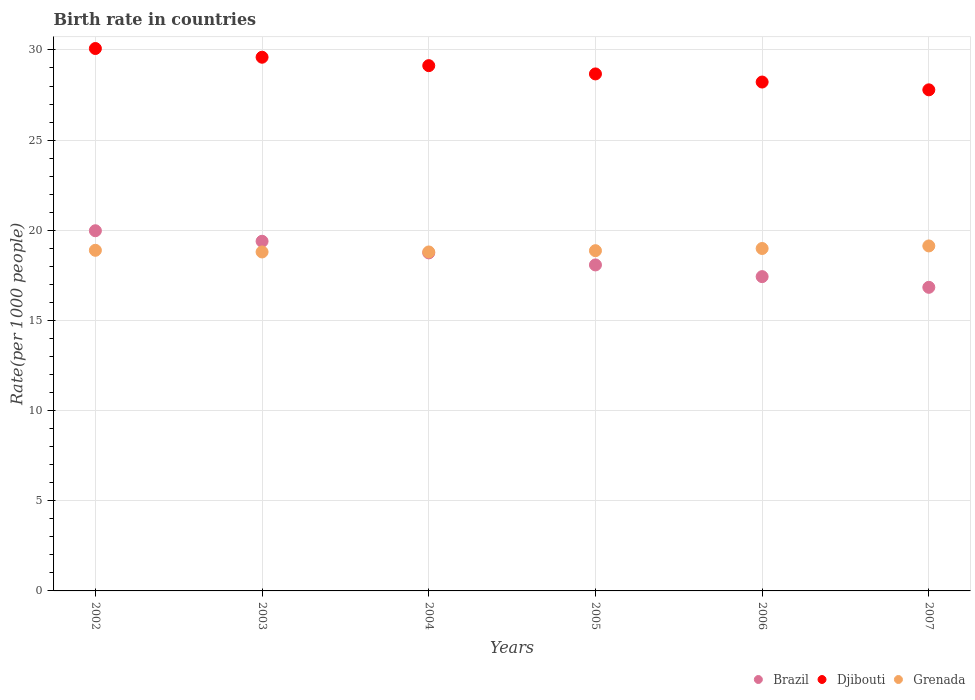What is the birth rate in Brazil in 2007?
Offer a terse response. 16.84. Across all years, what is the maximum birth rate in Grenada?
Offer a very short reply. 19.13. Across all years, what is the minimum birth rate in Brazil?
Offer a very short reply. 16.84. In which year was the birth rate in Brazil maximum?
Your response must be concise. 2002. In which year was the birth rate in Brazil minimum?
Your answer should be very brief. 2007. What is the total birth rate in Brazil in the graph?
Offer a very short reply. 110.45. What is the difference between the birth rate in Djibouti in 2006 and that in 2007?
Keep it short and to the point. 0.43. What is the difference between the birth rate in Djibouti in 2004 and the birth rate in Grenada in 2003?
Your answer should be compact. 10.33. What is the average birth rate in Brazil per year?
Your answer should be compact. 18.41. In the year 2005, what is the difference between the birth rate in Grenada and birth rate in Brazil?
Offer a very short reply. 0.79. What is the ratio of the birth rate in Djibouti in 2004 to that in 2005?
Your answer should be very brief. 1.02. Is the difference between the birth rate in Grenada in 2004 and 2007 greater than the difference between the birth rate in Brazil in 2004 and 2007?
Offer a very short reply. No. What is the difference between the highest and the second highest birth rate in Brazil?
Offer a terse response. 0.58. What is the difference between the highest and the lowest birth rate in Brazil?
Your answer should be compact. 3.14. In how many years, is the birth rate in Brazil greater than the average birth rate in Brazil taken over all years?
Your response must be concise. 3. Is the sum of the birth rate in Brazil in 2003 and 2004 greater than the maximum birth rate in Grenada across all years?
Provide a succinct answer. Yes. Is it the case that in every year, the sum of the birth rate in Brazil and birth rate in Grenada  is greater than the birth rate in Djibouti?
Your answer should be very brief. Yes. Does the birth rate in Brazil monotonically increase over the years?
Ensure brevity in your answer.  No. Is the birth rate in Djibouti strictly greater than the birth rate in Grenada over the years?
Provide a short and direct response. Yes. How many years are there in the graph?
Your response must be concise. 6. How many legend labels are there?
Make the answer very short. 3. How are the legend labels stacked?
Keep it short and to the point. Horizontal. What is the title of the graph?
Keep it short and to the point. Birth rate in countries. Does "Latin America(developing only)" appear as one of the legend labels in the graph?
Offer a very short reply. No. What is the label or title of the Y-axis?
Your response must be concise. Rate(per 1000 people). What is the Rate(per 1000 people) of Brazil in 2002?
Give a very brief answer. 19.97. What is the Rate(per 1000 people) of Djibouti in 2002?
Make the answer very short. 30.08. What is the Rate(per 1000 people) of Grenada in 2002?
Your response must be concise. 18.89. What is the Rate(per 1000 people) in Brazil in 2003?
Provide a short and direct response. 19.39. What is the Rate(per 1000 people) in Djibouti in 2003?
Keep it short and to the point. 29.6. What is the Rate(per 1000 people) of Grenada in 2003?
Offer a terse response. 18.8. What is the Rate(per 1000 people) in Brazil in 2004?
Make the answer very short. 18.75. What is the Rate(per 1000 people) in Djibouti in 2004?
Your answer should be very brief. 29.13. What is the Rate(per 1000 people) of Grenada in 2004?
Make the answer very short. 18.8. What is the Rate(per 1000 people) in Brazil in 2005?
Offer a terse response. 18.08. What is the Rate(per 1000 people) of Djibouti in 2005?
Your answer should be compact. 28.67. What is the Rate(per 1000 people) of Grenada in 2005?
Offer a very short reply. 18.87. What is the Rate(per 1000 people) in Brazil in 2006?
Make the answer very short. 17.43. What is the Rate(per 1000 people) in Djibouti in 2006?
Make the answer very short. 28.22. What is the Rate(per 1000 people) in Grenada in 2006?
Ensure brevity in your answer.  18.99. What is the Rate(per 1000 people) of Brazil in 2007?
Ensure brevity in your answer.  16.84. What is the Rate(per 1000 people) in Djibouti in 2007?
Your response must be concise. 27.79. What is the Rate(per 1000 people) in Grenada in 2007?
Your answer should be compact. 19.13. Across all years, what is the maximum Rate(per 1000 people) in Brazil?
Your answer should be very brief. 19.97. Across all years, what is the maximum Rate(per 1000 people) of Djibouti?
Provide a short and direct response. 30.08. Across all years, what is the maximum Rate(per 1000 people) in Grenada?
Make the answer very short. 19.13. Across all years, what is the minimum Rate(per 1000 people) of Brazil?
Keep it short and to the point. 16.84. Across all years, what is the minimum Rate(per 1000 people) in Djibouti?
Offer a very short reply. 27.79. Across all years, what is the minimum Rate(per 1000 people) of Grenada?
Keep it short and to the point. 18.8. What is the total Rate(per 1000 people) in Brazil in the graph?
Offer a very short reply. 110.45. What is the total Rate(per 1000 people) in Djibouti in the graph?
Your answer should be compact. 173.48. What is the total Rate(per 1000 people) of Grenada in the graph?
Provide a short and direct response. 113.47. What is the difference between the Rate(per 1000 people) of Brazil in 2002 and that in 2003?
Your response must be concise. 0.58. What is the difference between the Rate(per 1000 people) of Djibouti in 2002 and that in 2003?
Offer a very short reply. 0.48. What is the difference between the Rate(per 1000 people) in Grenada in 2002 and that in 2003?
Give a very brief answer. 0.09. What is the difference between the Rate(per 1000 people) of Brazil in 2002 and that in 2004?
Your response must be concise. 1.23. What is the difference between the Rate(per 1000 people) of Djibouti in 2002 and that in 2004?
Provide a succinct answer. 0.95. What is the difference between the Rate(per 1000 people) of Grenada in 2002 and that in 2004?
Your answer should be very brief. 0.09. What is the difference between the Rate(per 1000 people) in Brazil in 2002 and that in 2005?
Provide a succinct answer. 1.9. What is the difference between the Rate(per 1000 people) of Djibouti in 2002 and that in 2005?
Ensure brevity in your answer.  1.41. What is the difference between the Rate(per 1000 people) in Grenada in 2002 and that in 2005?
Provide a succinct answer. 0.02. What is the difference between the Rate(per 1000 people) of Brazil in 2002 and that in 2006?
Give a very brief answer. 2.54. What is the difference between the Rate(per 1000 people) of Djibouti in 2002 and that in 2006?
Your response must be concise. 1.86. What is the difference between the Rate(per 1000 people) in Brazil in 2002 and that in 2007?
Your answer should be compact. 3.14. What is the difference between the Rate(per 1000 people) of Djibouti in 2002 and that in 2007?
Give a very brief answer. 2.29. What is the difference between the Rate(per 1000 people) of Grenada in 2002 and that in 2007?
Make the answer very short. -0.24. What is the difference between the Rate(per 1000 people) in Brazil in 2003 and that in 2004?
Provide a succinct answer. 0.64. What is the difference between the Rate(per 1000 people) in Djibouti in 2003 and that in 2004?
Your answer should be very brief. 0.47. What is the difference between the Rate(per 1000 people) in Grenada in 2003 and that in 2004?
Your answer should be compact. 0. What is the difference between the Rate(per 1000 people) in Brazil in 2003 and that in 2005?
Make the answer very short. 1.31. What is the difference between the Rate(per 1000 people) of Djibouti in 2003 and that in 2005?
Provide a succinct answer. 0.93. What is the difference between the Rate(per 1000 people) in Grenada in 2003 and that in 2005?
Your response must be concise. -0.07. What is the difference between the Rate(per 1000 people) in Brazil in 2003 and that in 2006?
Provide a succinct answer. 1.96. What is the difference between the Rate(per 1000 people) of Djibouti in 2003 and that in 2006?
Make the answer very short. 1.38. What is the difference between the Rate(per 1000 people) in Grenada in 2003 and that in 2006?
Keep it short and to the point. -0.19. What is the difference between the Rate(per 1000 people) of Brazil in 2003 and that in 2007?
Offer a terse response. 2.55. What is the difference between the Rate(per 1000 people) in Djibouti in 2003 and that in 2007?
Make the answer very short. 1.81. What is the difference between the Rate(per 1000 people) of Grenada in 2003 and that in 2007?
Your answer should be very brief. -0.33. What is the difference between the Rate(per 1000 people) of Brazil in 2004 and that in 2005?
Offer a very short reply. 0.67. What is the difference between the Rate(per 1000 people) of Djibouti in 2004 and that in 2005?
Keep it short and to the point. 0.46. What is the difference between the Rate(per 1000 people) in Grenada in 2004 and that in 2005?
Your response must be concise. -0.07. What is the difference between the Rate(per 1000 people) of Brazil in 2004 and that in 2006?
Your answer should be very brief. 1.32. What is the difference between the Rate(per 1000 people) of Djibouti in 2004 and that in 2006?
Keep it short and to the point. 0.91. What is the difference between the Rate(per 1000 people) of Grenada in 2004 and that in 2006?
Make the answer very short. -0.19. What is the difference between the Rate(per 1000 people) of Brazil in 2004 and that in 2007?
Offer a terse response. 1.91. What is the difference between the Rate(per 1000 people) of Djibouti in 2004 and that in 2007?
Your response must be concise. 1.34. What is the difference between the Rate(per 1000 people) of Grenada in 2004 and that in 2007?
Ensure brevity in your answer.  -0.33. What is the difference between the Rate(per 1000 people) in Brazil in 2005 and that in 2006?
Keep it short and to the point. 0.65. What is the difference between the Rate(per 1000 people) in Djibouti in 2005 and that in 2006?
Your answer should be compact. 0.45. What is the difference between the Rate(per 1000 people) in Grenada in 2005 and that in 2006?
Make the answer very short. -0.12. What is the difference between the Rate(per 1000 people) in Brazil in 2005 and that in 2007?
Make the answer very short. 1.24. What is the difference between the Rate(per 1000 people) in Djibouti in 2005 and that in 2007?
Make the answer very short. 0.88. What is the difference between the Rate(per 1000 people) in Grenada in 2005 and that in 2007?
Give a very brief answer. -0.26. What is the difference between the Rate(per 1000 people) of Brazil in 2006 and that in 2007?
Your answer should be very brief. 0.59. What is the difference between the Rate(per 1000 people) in Djibouti in 2006 and that in 2007?
Ensure brevity in your answer.  0.43. What is the difference between the Rate(per 1000 people) in Grenada in 2006 and that in 2007?
Provide a short and direct response. -0.14. What is the difference between the Rate(per 1000 people) of Brazil in 2002 and the Rate(per 1000 people) of Djibouti in 2003?
Ensure brevity in your answer.  -9.62. What is the difference between the Rate(per 1000 people) of Brazil in 2002 and the Rate(per 1000 people) of Grenada in 2003?
Ensure brevity in your answer.  1.18. What is the difference between the Rate(per 1000 people) of Djibouti in 2002 and the Rate(per 1000 people) of Grenada in 2003?
Make the answer very short. 11.28. What is the difference between the Rate(per 1000 people) of Brazil in 2002 and the Rate(per 1000 people) of Djibouti in 2004?
Keep it short and to the point. -9.15. What is the difference between the Rate(per 1000 people) of Brazil in 2002 and the Rate(per 1000 people) of Grenada in 2004?
Offer a terse response. 1.18. What is the difference between the Rate(per 1000 people) of Djibouti in 2002 and the Rate(per 1000 people) of Grenada in 2004?
Provide a short and direct response. 11.28. What is the difference between the Rate(per 1000 people) in Brazil in 2002 and the Rate(per 1000 people) in Djibouti in 2005?
Provide a succinct answer. -8.7. What is the difference between the Rate(per 1000 people) in Brazil in 2002 and the Rate(per 1000 people) in Grenada in 2005?
Make the answer very short. 1.11. What is the difference between the Rate(per 1000 people) of Djibouti in 2002 and the Rate(per 1000 people) of Grenada in 2005?
Your answer should be very brief. 11.21. What is the difference between the Rate(per 1000 people) of Brazil in 2002 and the Rate(per 1000 people) of Djibouti in 2006?
Your answer should be very brief. -8.25. What is the difference between the Rate(per 1000 people) of Djibouti in 2002 and the Rate(per 1000 people) of Grenada in 2006?
Your answer should be very brief. 11.09. What is the difference between the Rate(per 1000 people) in Brazil in 2002 and the Rate(per 1000 people) in Djibouti in 2007?
Provide a short and direct response. -7.81. What is the difference between the Rate(per 1000 people) in Brazil in 2002 and the Rate(per 1000 people) in Grenada in 2007?
Your answer should be compact. 0.84. What is the difference between the Rate(per 1000 people) of Djibouti in 2002 and the Rate(per 1000 people) of Grenada in 2007?
Make the answer very short. 10.95. What is the difference between the Rate(per 1000 people) in Brazil in 2003 and the Rate(per 1000 people) in Djibouti in 2004?
Offer a very short reply. -9.74. What is the difference between the Rate(per 1000 people) in Brazil in 2003 and the Rate(per 1000 people) in Grenada in 2004?
Provide a succinct answer. 0.59. What is the difference between the Rate(per 1000 people) of Djibouti in 2003 and the Rate(per 1000 people) of Grenada in 2004?
Make the answer very short. 10.8. What is the difference between the Rate(per 1000 people) in Brazil in 2003 and the Rate(per 1000 people) in Djibouti in 2005?
Make the answer very short. -9.28. What is the difference between the Rate(per 1000 people) of Brazil in 2003 and the Rate(per 1000 people) of Grenada in 2005?
Make the answer very short. 0.52. What is the difference between the Rate(per 1000 people) of Djibouti in 2003 and the Rate(per 1000 people) of Grenada in 2005?
Provide a short and direct response. 10.73. What is the difference between the Rate(per 1000 people) of Brazil in 2003 and the Rate(per 1000 people) of Djibouti in 2006?
Your answer should be compact. -8.83. What is the difference between the Rate(per 1000 people) of Brazil in 2003 and the Rate(per 1000 people) of Grenada in 2006?
Offer a terse response. 0.4. What is the difference between the Rate(per 1000 people) in Djibouti in 2003 and the Rate(per 1000 people) in Grenada in 2006?
Make the answer very short. 10.61. What is the difference between the Rate(per 1000 people) in Brazil in 2003 and the Rate(per 1000 people) in Djibouti in 2007?
Your answer should be very brief. -8.4. What is the difference between the Rate(per 1000 people) in Brazil in 2003 and the Rate(per 1000 people) in Grenada in 2007?
Give a very brief answer. 0.26. What is the difference between the Rate(per 1000 people) of Djibouti in 2003 and the Rate(per 1000 people) of Grenada in 2007?
Make the answer very short. 10.46. What is the difference between the Rate(per 1000 people) of Brazil in 2004 and the Rate(per 1000 people) of Djibouti in 2005?
Keep it short and to the point. -9.92. What is the difference between the Rate(per 1000 people) of Brazil in 2004 and the Rate(per 1000 people) of Grenada in 2005?
Keep it short and to the point. -0.12. What is the difference between the Rate(per 1000 people) of Djibouti in 2004 and the Rate(per 1000 people) of Grenada in 2005?
Offer a terse response. 10.26. What is the difference between the Rate(per 1000 people) in Brazil in 2004 and the Rate(per 1000 people) in Djibouti in 2006?
Make the answer very short. -9.47. What is the difference between the Rate(per 1000 people) of Brazil in 2004 and the Rate(per 1000 people) of Grenada in 2006?
Give a very brief answer. -0.24. What is the difference between the Rate(per 1000 people) in Djibouti in 2004 and the Rate(per 1000 people) in Grenada in 2006?
Keep it short and to the point. 10.14. What is the difference between the Rate(per 1000 people) in Brazil in 2004 and the Rate(per 1000 people) in Djibouti in 2007?
Offer a very short reply. -9.04. What is the difference between the Rate(per 1000 people) in Brazil in 2004 and the Rate(per 1000 people) in Grenada in 2007?
Your answer should be very brief. -0.39. What is the difference between the Rate(per 1000 people) in Djibouti in 2004 and the Rate(per 1000 people) in Grenada in 2007?
Provide a short and direct response. 10. What is the difference between the Rate(per 1000 people) of Brazil in 2005 and the Rate(per 1000 people) of Djibouti in 2006?
Keep it short and to the point. -10.14. What is the difference between the Rate(per 1000 people) of Brazil in 2005 and the Rate(per 1000 people) of Grenada in 2006?
Your answer should be very brief. -0.91. What is the difference between the Rate(per 1000 people) of Djibouti in 2005 and the Rate(per 1000 people) of Grenada in 2006?
Your response must be concise. 9.68. What is the difference between the Rate(per 1000 people) of Brazil in 2005 and the Rate(per 1000 people) of Djibouti in 2007?
Keep it short and to the point. -9.71. What is the difference between the Rate(per 1000 people) in Brazil in 2005 and the Rate(per 1000 people) in Grenada in 2007?
Give a very brief answer. -1.05. What is the difference between the Rate(per 1000 people) in Djibouti in 2005 and the Rate(per 1000 people) in Grenada in 2007?
Keep it short and to the point. 9.54. What is the difference between the Rate(per 1000 people) in Brazil in 2006 and the Rate(per 1000 people) in Djibouti in 2007?
Your answer should be compact. -10.36. What is the difference between the Rate(per 1000 people) in Brazil in 2006 and the Rate(per 1000 people) in Grenada in 2007?
Offer a very short reply. -1.7. What is the difference between the Rate(per 1000 people) in Djibouti in 2006 and the Rate(per 1000 people) in Grenada in 2007?
Give a very brief answer. 9.09. What is the average Rate(per 1000 people) in Brazil per year?
Your answer should be very brief. 18.41. What is the average Rate(per 1000 people) of Djibouti per year?
Your response must be concise. 28.91. What is the average Rate(per 1000 people) in Grenada per year?
Give a very brief answer. 18.91. In the year 2002, what is the difference between the Rate(per 1000 people) of Brazil and Rate(per 1000 people) of Djibouti?
Your answer should be compact. -10.11. In the year 2002, what is the difference between the Rate(per 1000 people) in Brazil and Rate(per 1000 people) in Grenada?
Your answer should be compact. 1.08. In the year 2002, what is the difference between the Rate(per 1000 people) of Djibouti and Rate(per 1000 people) of Grenada?
Offer a terse response. 11.19. In the year 2003, what is the difference between the Rate(per 1000 people) of Brazil and Rate(per 1000 people) of Djibouti?
Provide a succinct answer. -10.21. In the year 2003, what is the difference between the Rate(per 1000 people) in Brazil and Rate(per 1000 people) in Grenada?
Ensure brevity in your answer.  0.59. In the year 2003, what is the difference between the Rate(per 1000 people) in Djibouti and Rate(per 1000 people) in Grenada?
Give a very brief answer. 10.8. In the year 2004, what is the difference between the Rate(per 1000 people) of Brazil and Rate(per 1000 people) of Djibouti?
Your response must be concise. -10.38. In the year 2004, what is the difference between the Rate(per 1000 people) of Brazil and Rate(per 1000 people) of Grenada?
Ensure brevity in your answer.  -0.05. In the year 2004, what is the difference between the Rate(per 1000 people) in Djibouti and Rate(per 1000 people) in Grenada?
Offer a terse response. 10.33. In the year 2005, what is the difference between the Rate(per 1000 people) in Brazil and Rate(per 1000 people) in Djibouti?
Give a very brief answer. -10.59. In the year 2005, what is the difference between the Rate(per 1000 people) in Brazil and Rate(per 1000 people) in Grenada?
Keep it short and to the point. -0.79. In the year 2005, what is the difference between the Rate(per 1000 people) in Djibouti and Rate(per 1000 people) in Grenada?
Your answer should be very brief. 9.8. In the year 2006, what is the difference between the Rate(per 1000 people) in Brazil and Rate(per 1000 people) in Djibouti?
Keep it short and to the point. -10.79. In the year 2006, what is the difference between the Rate(per 1000 people) in Brazil and Rate(per 1000 people) in Grenada?
Ensure brevity in your answer.  -1.56. In the year 2006, what is the difference between the Rate(per 1000 people) of Djibouti and Rate(per 1000 people) of Grenada?
Make the answer very short. 9.23. In the year 2007, what is the difference between the Rate(per 1000 people) in Brazil and Rate(per 1000 people) in Djibouti?
Offer a terse response. -10.95. In the year 2007, what is the difference between the Rate(per 1000 people) of Brazil and Rate(per 1000 people) of Grenada?
Your response must be concise. -2.29. In the year 2007, what is the difference between the Rate(per 1000 people) in Djibouti and Rate(per 1000 people) in Grenada?
Offer a terse response. 8.66. What is the ratio of the Rate(per 1000 people) in Brazil in 2002 to that in 2003?
Your answer should be compact. 1.03. What is the ratio of the Rate(per 1000 people) of Djibouti in 2002 to that in 2003?
Your answer should be compact. 1.02. What is the ratio of the Rate(per 1000 people) in Grenada in 2002 to that in 2003?
Keep it short and to the point. 1. What is the ratio of the Rate(per 1000 people) in Brazil in 2002 to that in 2004?
Give a very brief answer. 1.07. What is the ratio of the Rate(per 1000 people) in Djibouti in 2002 to that in 2004?
Provide a succinct answer. 1.03. What is the ratio of the Rate(per 1000 people) of Brazil in 2002 to that in 2005?
Offer a very short reply. 1.1. What is the ratio of the Rate(per 1000 people) of Djibouti in 2002 to that in 2005?
Make the answer very short. 1.05. What is the ratio of the Rate(per 1000 people) of Grenada in 2002 to that in 2005?
Ensure brevity in your answer.  1. What is the ratio of the Rate(per 1000 people) in Brazil in 2002 to that in 2006?
Offer a terse response. 1.15. What is the ratio of the Rate(per 1000 people) of Djibouti in 2002 to that in 2006?
Your answer should be very brief. 1.07. What is the ratio of the Rate(per 1000 people) of Grenada in 2002 to that in 2006?
Give a very brief answer. 0.99. What is the ratio of the Rate(per 1000 people) in Brazil in 2002 to that in 2007?
Your answer should be very brief. 1.19. What is the ratio of the Rate(per 1000 people) of Djibouti in 2002 to that in 2007?
Provide a short and direct response. 1.08. What is the ratio of the Rate(per 1000 people) of Grenada in 2002 to that in 2007?
Your answer should be very brief. 0.99. What is the ratio of the Rate(per 1000 people) in Brazil in 2003 to that in 2004?
Ensure brevity in your answer.  1.03. What is the ratio of the Rate(per 1000 people) of Grenada in 2003 to that in 2004?
Give a very brief answer. 1. What is the ratio of the Rate(per 1000 people) in Brazil in 2003 to that in 2005?
Your answer should be compact. 1.07. What is the ratio of the Rate(per 1000 people) of Djibouti in 2003 to that in 2005?
Your answer should be compact. 1.03. What is the ratio of the Rate(per 1000 people) of Brazil in 2003 to that in 2006?
Offer a terse response. 1.11. What is the ratio of the Rate(per 1000 people) of Djibouti in 2003 to that in 2006?
Your answer should be compact. 1.05. What is the ratio of the Rate(per 1000 people) of Grenada in 2003 to that in 2006?
Give a very brief answer. 0.99. What is the ratio of the Rate(per 1000 people) in Brazil in 2003 to that in 2007?
Provide a succinct answer. 1.15. What is the ratio of the Rate(per 1000 people) of Djibouti in 2003 to that in 2007?
Your response must be concise. 1.07. What is the ratio of the Rate(per 1000 people) of Grenada in 2003 to that in 2007?
Offer a very short reply. 0.98. What is the ratio of the Rate(per 1000 people) of Brazil in 2004 to that in 2005?
Give a very brief answer. 1.04. What is the ratio of the Rate(per 1000 people) of Djibouti in 2004 to that in 2005?
Your answer should be compact. 1.02. What is the ratio of the Rate(per 1000 people) in Brazil in 2004 to that in 2006?
Your response must be concise. 1.08. What is the ratio of the Rate(per 1000 people) of Djibouti in 2004 to that in 2006?
Give a very brief answer. 1.03. What is the ratio of the Rate(per 1000 people) of Grenada in 2004 to that in 2006?
Offer a terse response. 0.99. What is the ratio of the Rate(per 1000 people) of Brazil in 2004 to that in 2007?
Your answer should be compact. 1.11. What is the ratio of the Rate(per 1000 people) of Djibouti in 2004 to that in 2007?
Provide a short and direct response. 1.05. What is the ratio of the Rate(per 1000 people) in Grenada in 2004 to that in 2007?
Ensure brevity in your answer.  0.98. What is the ratio of the Rate(per 1000 people) in Brazil in 2005 to that in 2006?
Provide a short and direct response. 1.04. What is the ratio of the Rate(per 1000 people) of Djibouti in 2005 to that in 2006?
Give a very brief answer. 1.02. What is the ratio of the Rate(per 1000 people) of Grenada in 2005 to that in 2006?
Provide a short and direct response. 0.99. What is the ratio of the Rate(per 1000 people) in Brazil in 2005 to that in 2007?
Provide a succinct answer. 1.07. What is the ratio of the Rate(per 1000 people) of Djibouti in 2005 to that in 2007?
Offer a very short reply. 1.03. What is the ratio of the Rate(per 1000 people) of Grenada in 2005 to that in 2007?
Provide a short and direct response. 0.99. What is the ratio of the Rate(per 1000 people) in Brazil in 2006 to that in 2007?
Offer a very short reply. 1.04. What is the ratio of the Rate(per 1000 people) in Djibouti in 2006 to that in 2007?
Your response must be concise. 1.02. What is the ratio of the Rate(per 1000 people) in Grenada in 2006 to that in 2007?
Your answer should be compact. 0.99. What is the difference between the highest and the second highest Rate(per 1000 people) of Brazil?
Keep it short and to the point. 0.58. What is the difference between the highest and the second highest Rate(per 1000 people) in Djibouti?
Provide a short and direct response. 0.48. What is the difference between the highest and the second highest Rate(per 1000 people) in Grenada?
Offer a terse response. 0.14. What is the difference between the highest and the lowest Rate(per 1000 people) in Brazil?
Give a very brief answer. 3.14. What is the difference between the highest and the lowest Rate(per 1000 people) in Djibouti?
Your answer should be compact. 2.29. What is the difference between the highest and the lowest Rate(per 1000 people) in Grenada?
Give a very brief answer. 0.33. 